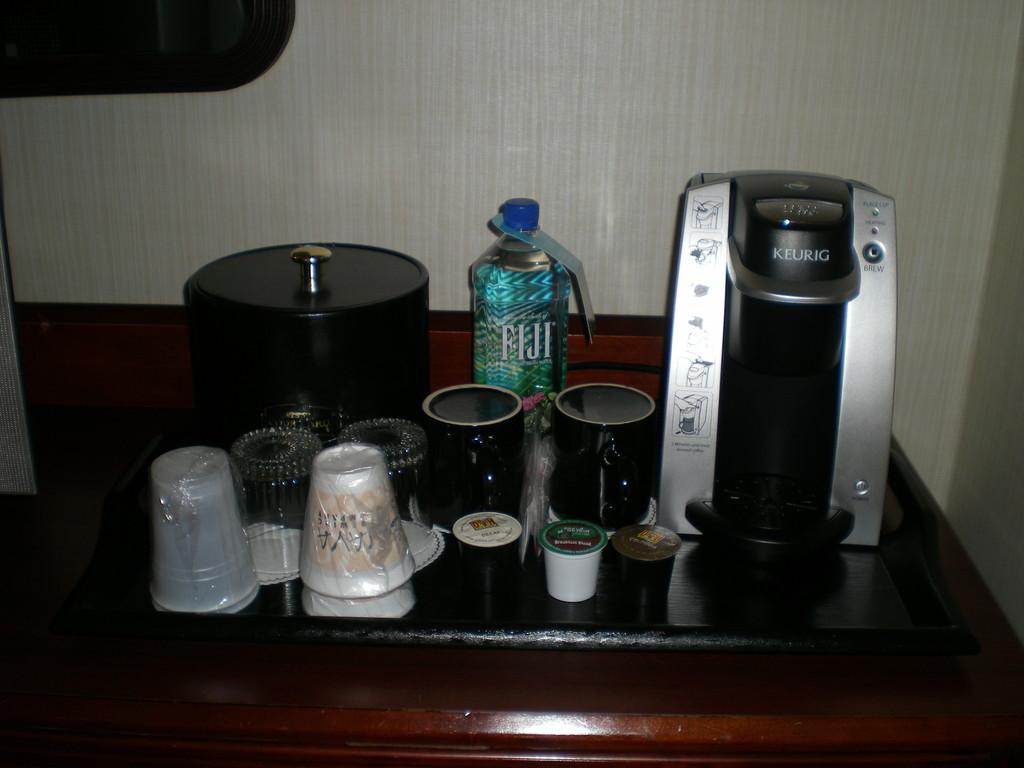<image>
Relay a brief, clear account of the picture shown. a bottle of fiji water sitting on a desk behind two mugs 